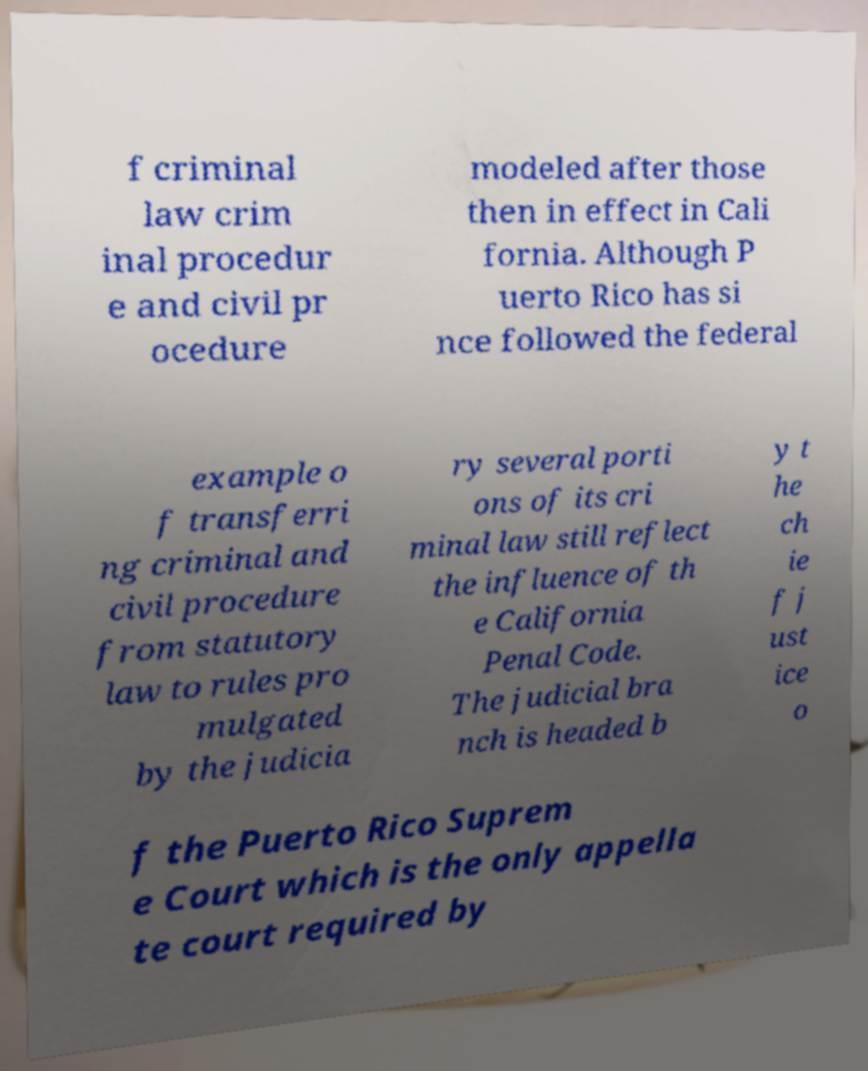Can you read and provide the text displayed in the image?This photo seems to have some interesting text. Can you extract and type it out for me? f criminal law crim inal procedur e and civil pr ocedure modeled after those then in effect in Cali fornia. Although P uerto Rico has si nce followed the federal example o f transferri ng criminal and civil procedure from statutory law to rules pro mulgated by the judicia ry several porti ons of its cri minal law still reflect the influence of th e California Penal Code. The judicial bra nch is headed b y t he ch ie f j ust ice o f the Puerto Rico Suprem e Court which is the only appella te court required by 